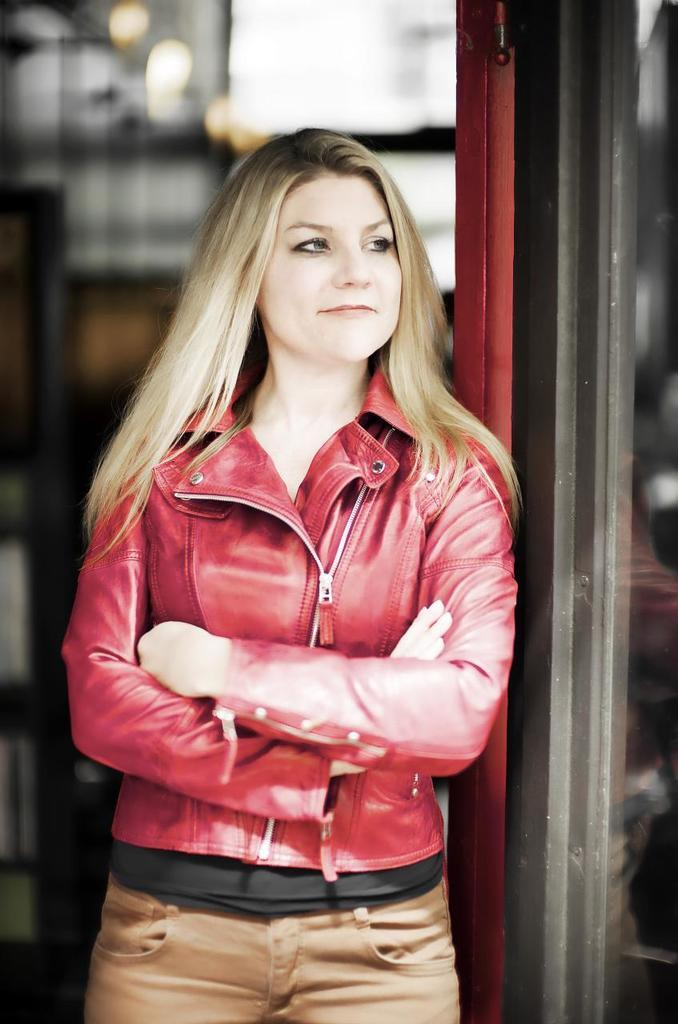Who is in the picture? There is a woman in the picture. What is the woman wearing? The woman is wearing a red jacket. Where is the woman standing in relation to the door? The woman is standing beside a door. Can you describe the background of the woman? The background of the woman is blurred. What type of pizzas can be seen in the background of the image? There are no pizzas present in the image; the background is blurred. 